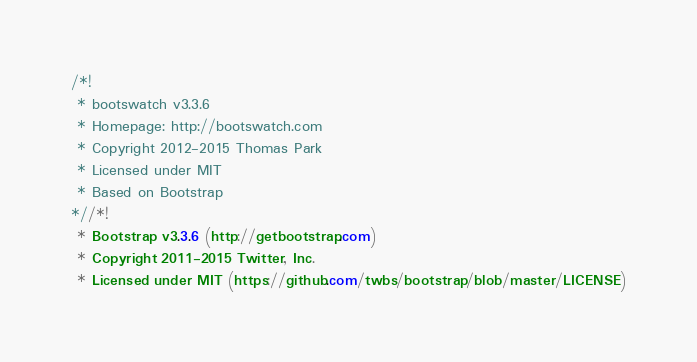<code> <loc_0><loc_0><loc_500><loc_500><_CSS_>/*!
 * bootswatch v3.3.6
 * Homepage: http://bootswatch.com
 * Copyright 2012-2015 Thomas Park
 * Licensed under MIT
 * Based on Bootstrap
*//*!
 * Bootstrap v3.3.6 (http://getbootstrap.com)
 * Copyright 2011-2015 Twitter, Inc.
 * Licensed under MIT (https://github.com/twbs/bootstrap/blob/master/LICENSE)</code> 